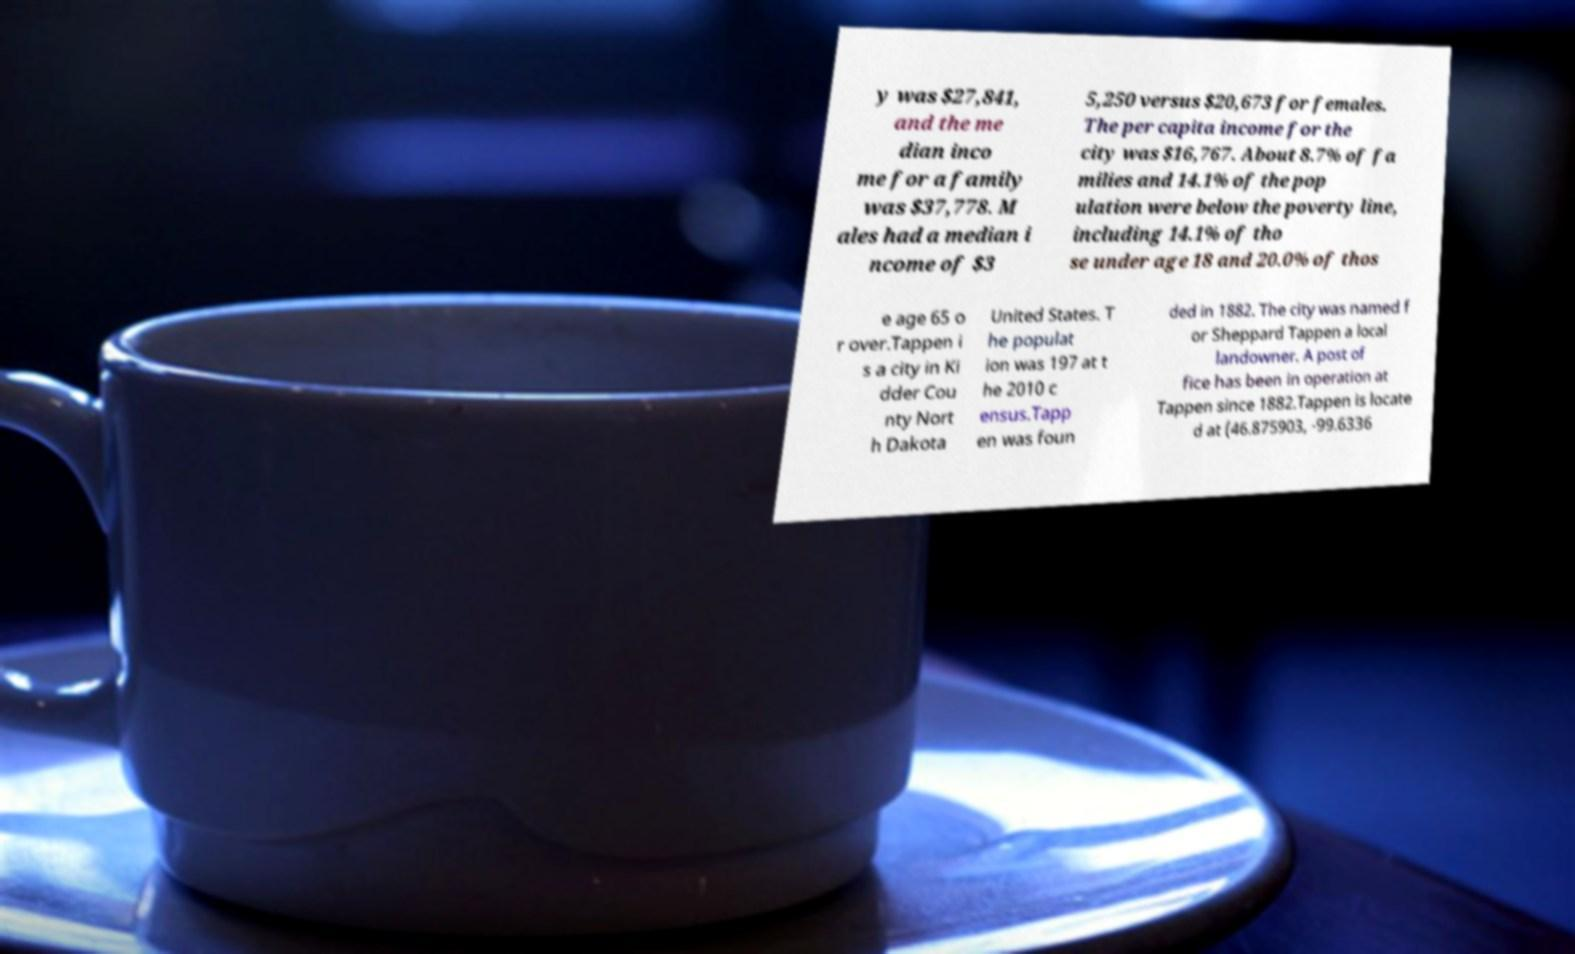Can you read and provide the text displayed in the image?This photo seems to have some interesting text. Can you extract and type it out for me? y was $27,841, and the me dian inco me for a family was $37,778. M ales had a median i ncome of $3 5,250 versus $20,673 for females. The per capita income for the city was $16,767. About 8.7% of fa milies and 14.1% of the pop ulation were below the poverty line, including 14.1% of tho se under age 18 and 20.0% of thos e age 65 o r over.Tappen i s a city in Ki dder Cou nty Nort h Dakota United States. T he populat ion was 197 at t he 2010 c ensus.Tapp en was foun ded in 1882. The city was named f or Sheppard Tappen a local landowner. A post of fice has been in operation at Tappen since 1882.Tappen is locate d at (46.875903, -99.6336 